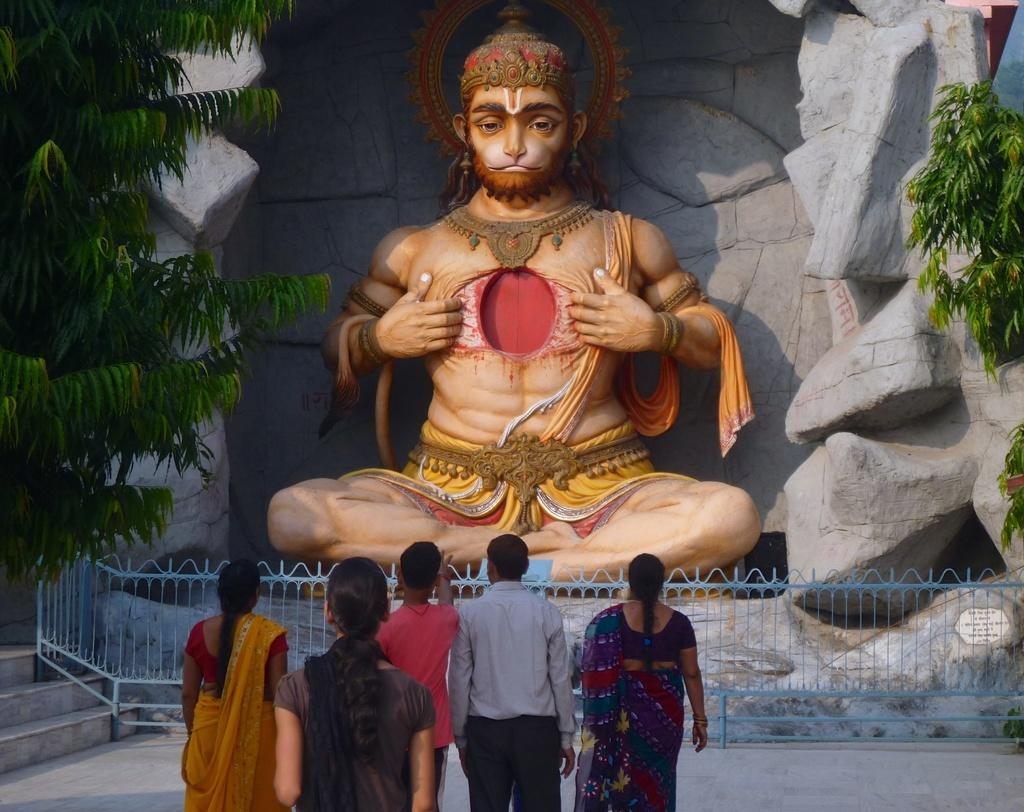What is the main subject in the image? There is a statue in the image. Are there any other people or objects in the image? Yes, there are people in the image, as well as a railing, steps, trees, and a wall with rocks in the background. What might the people be doing near the statue? It is not clear from the image what the people are doing, but they could be observing the statue or using the steps. What type of vegetation is present in the image? Trees are present in the image. What flavor of cushion can be seen on the statue in the image? There is no cushion present in the image, and therefore no flavor can be determined. 